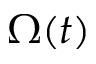Convert formula to latex. <formula><loc_0><loc_0><loc_500><loc_500>\Omega ( t )</formula> 